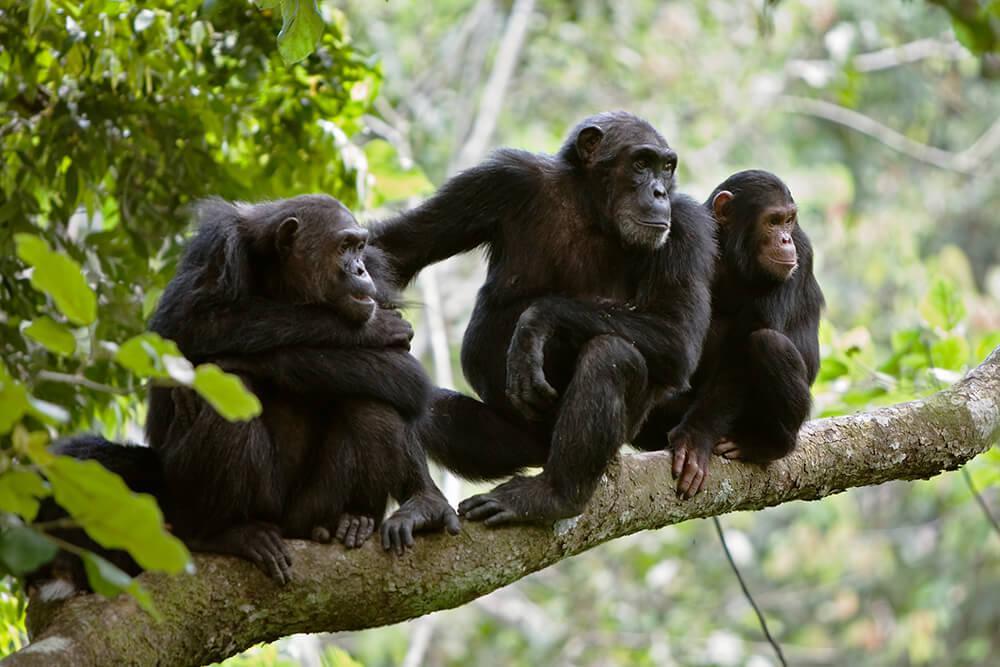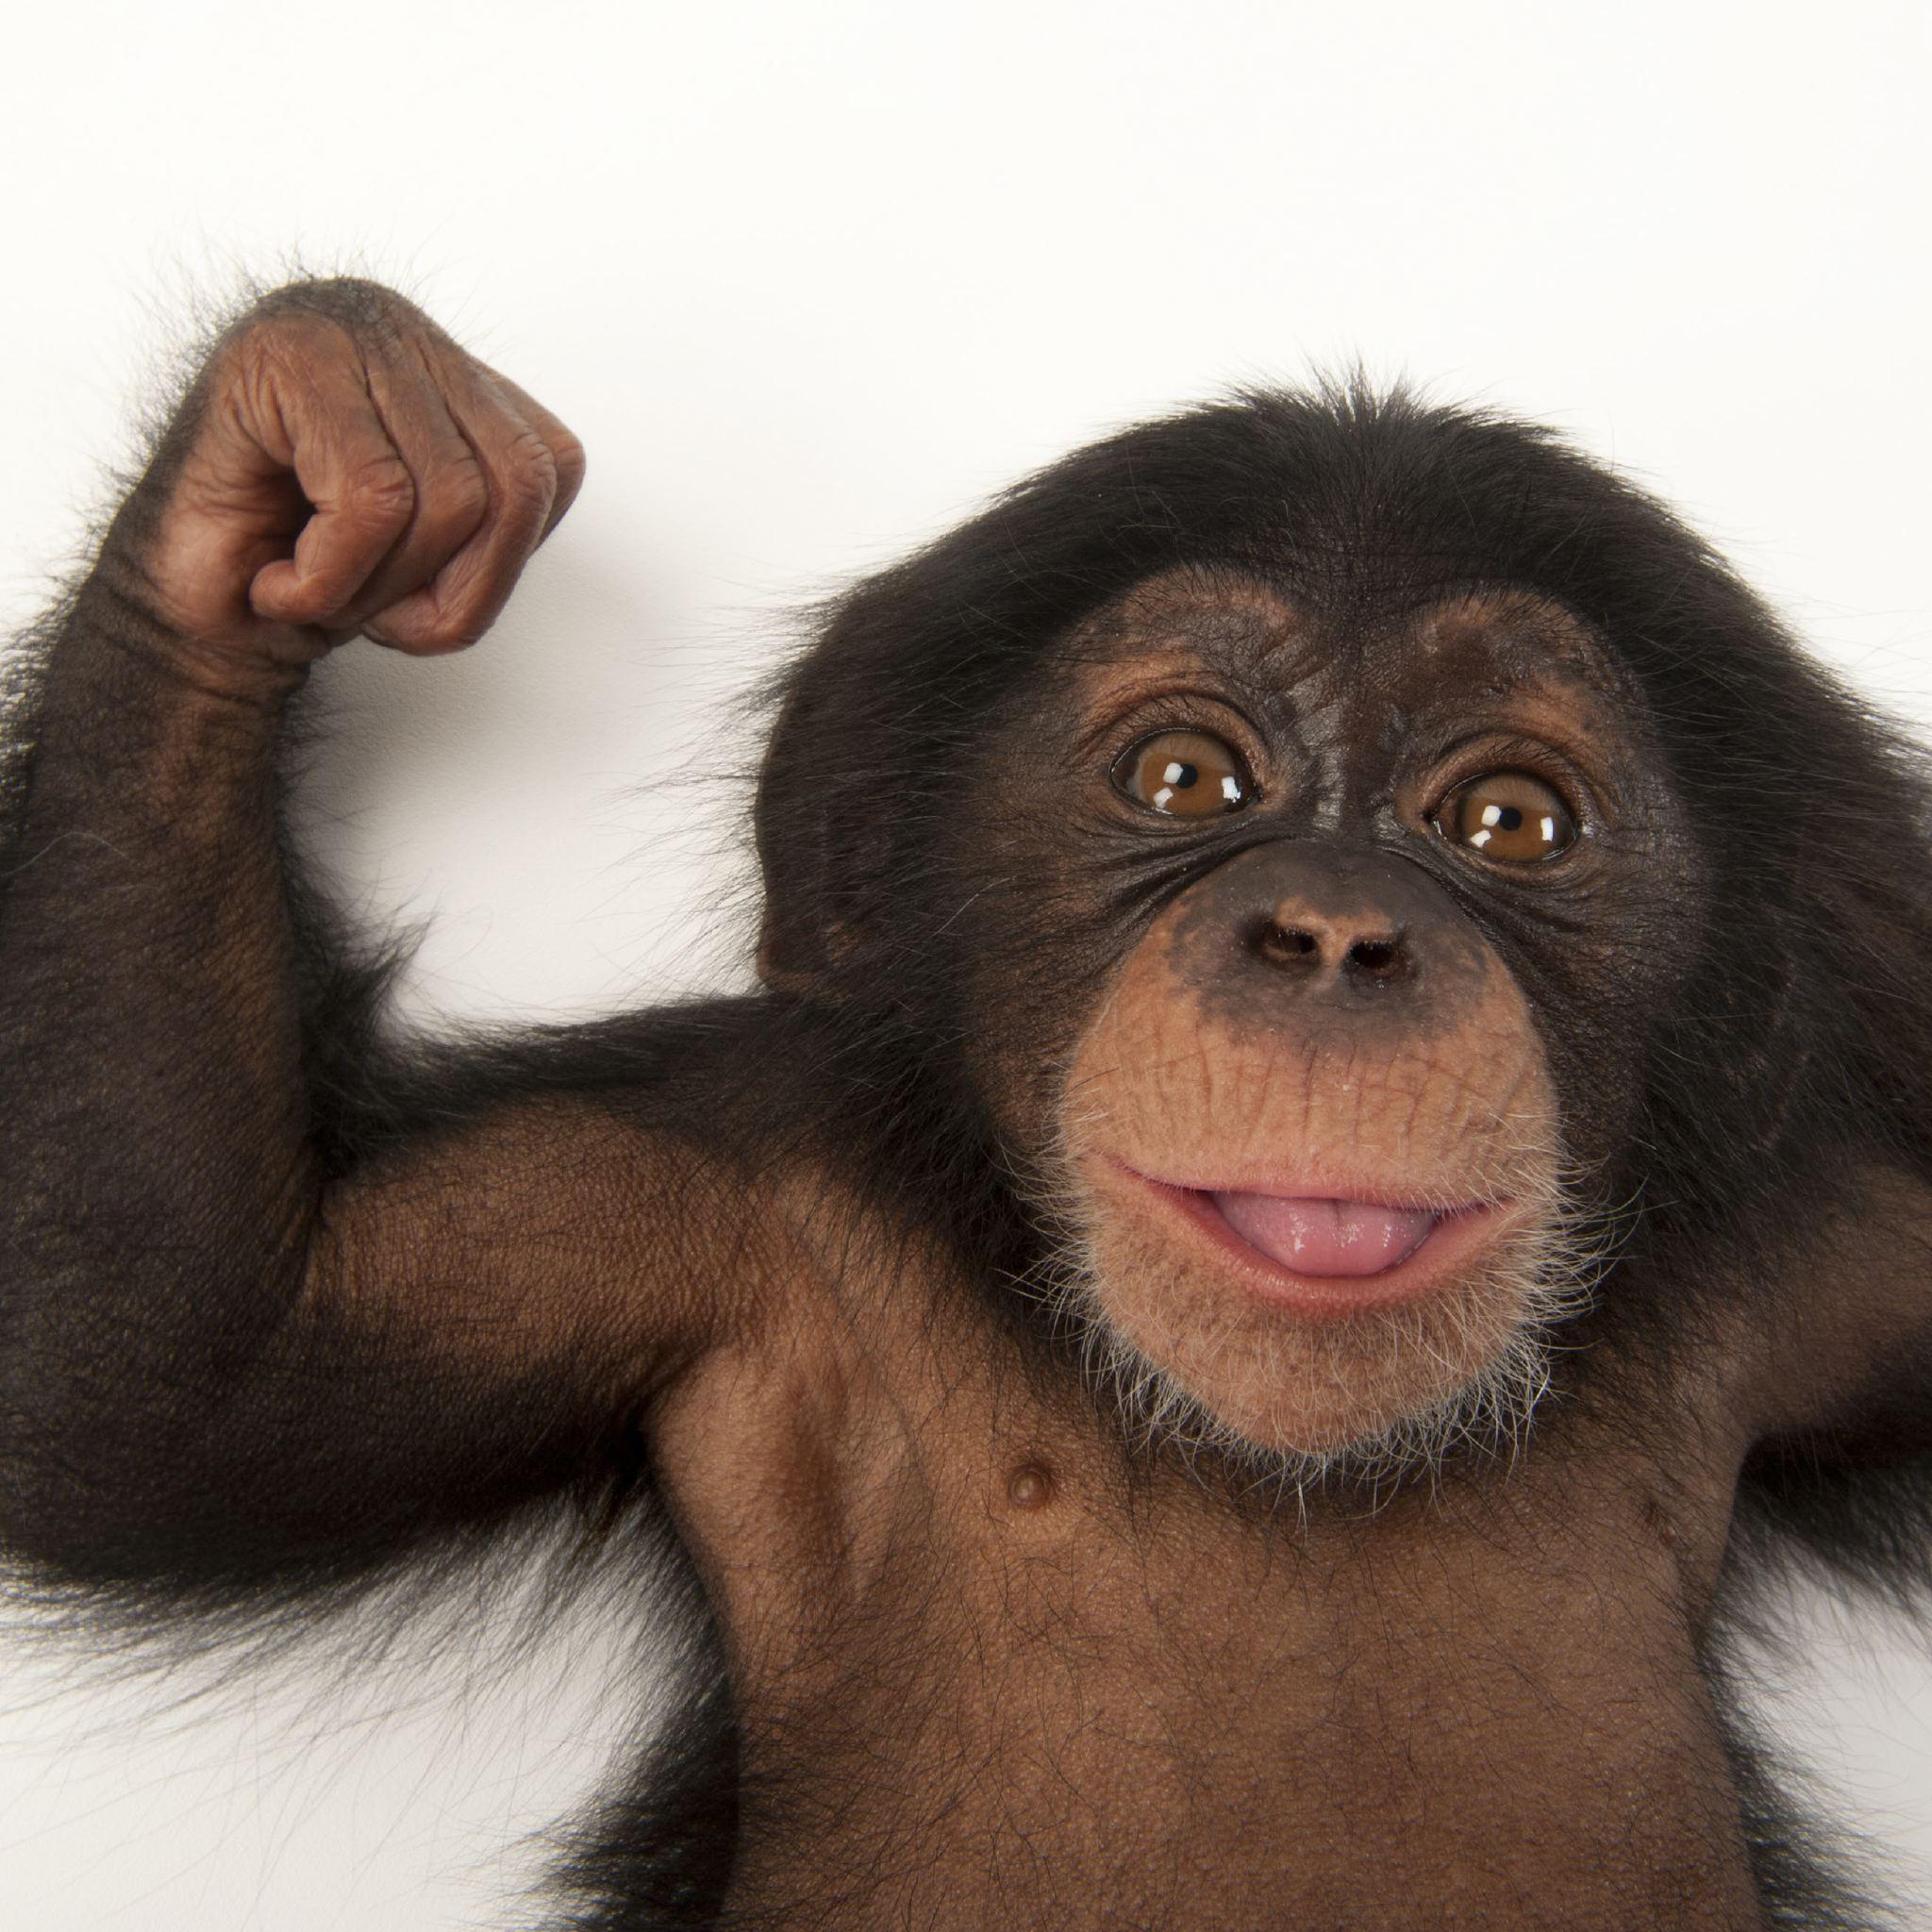The first image is the image on the left, the second image is the image on the right. Assess this claim about the two images: "There are four monkey-type animals including very young ones.". Correct or not? Answer yes or no. Yes. The first image is the image on the left, the second image is the image on the right. Given the left and right images, does the statement "Just one adult and one young chimp are interacting side-by-side in the left image." hold true? Answer yes or no. No. The first image is the image on the left, the second image is the image on the right. Considering the images on both sides, is "There is exactly one baby monkey in the image on the right." valid? Answer yes or no. Yes. 